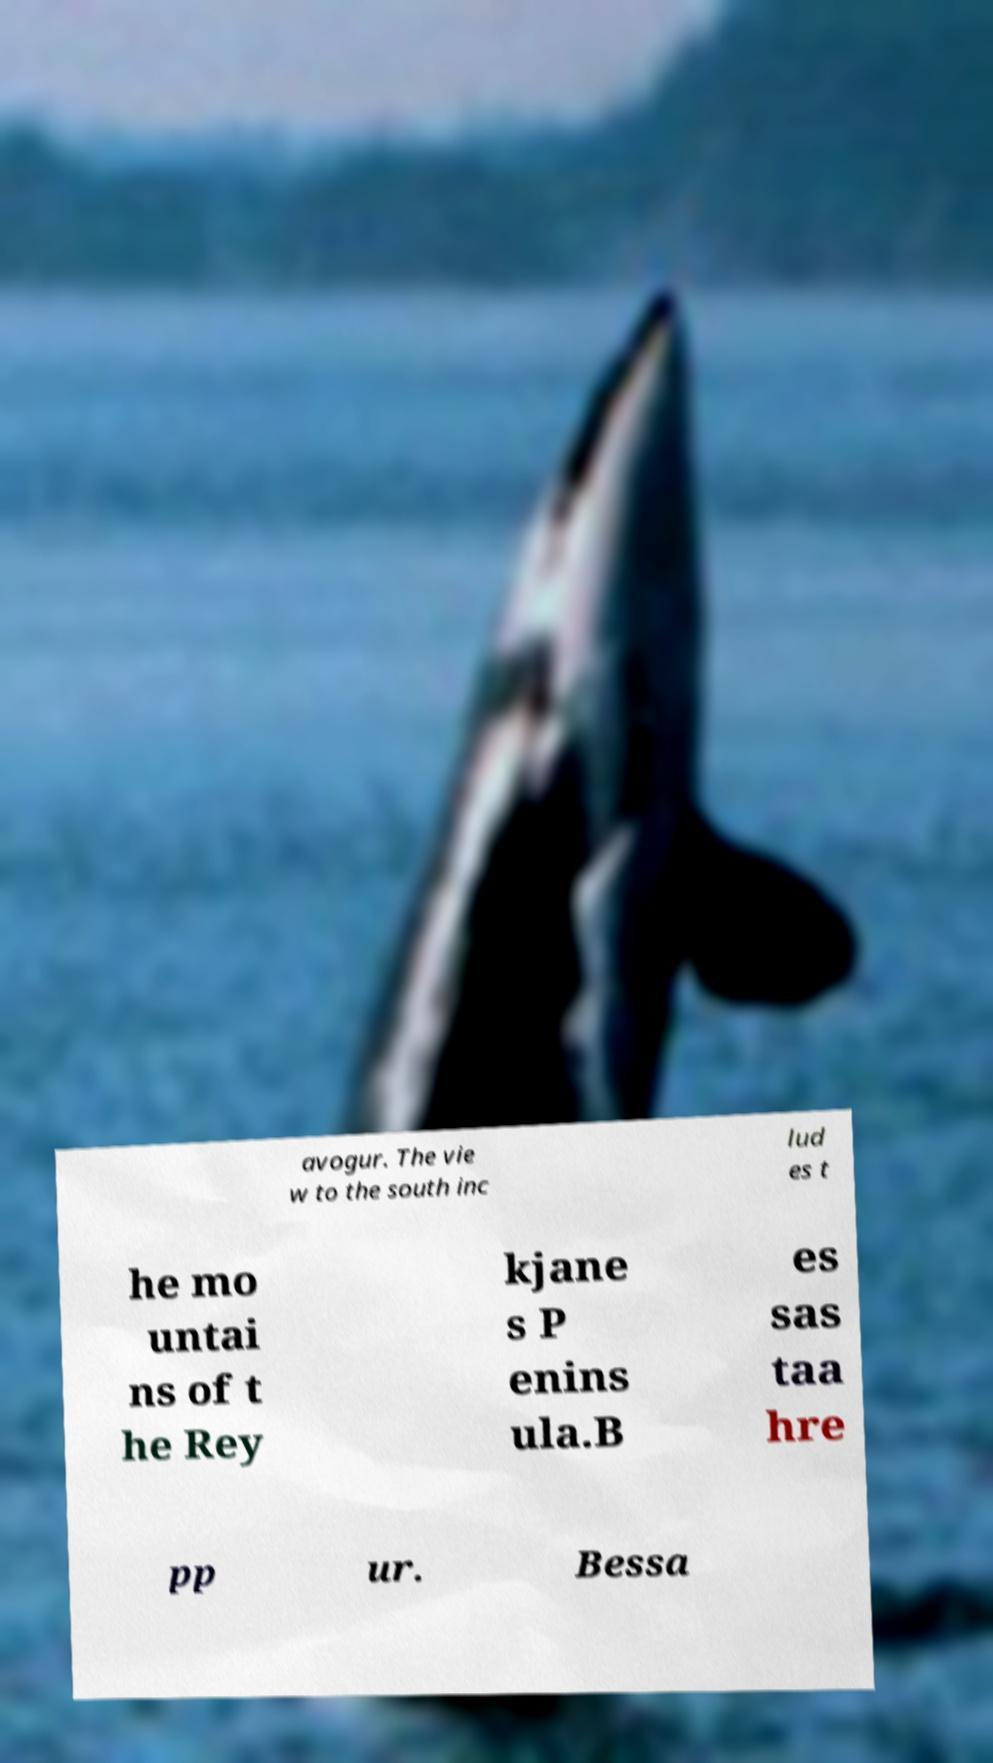Could you assist in decoding the text presented in this image and type it out clearly? avogur. The vie w to the south inc lud es t he mo untai ns of t he Rey kjane s P enins ula.B es sas taa hre pp ur. Bessa 